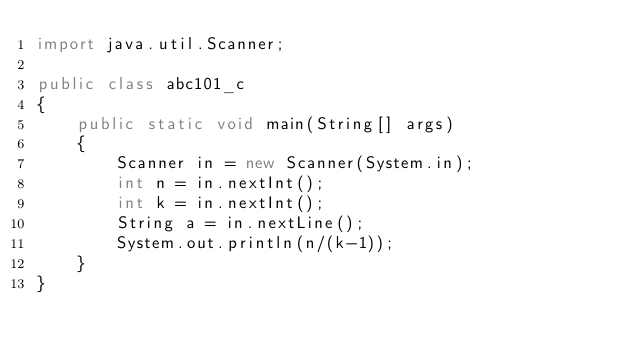<code> <loc_0><loc_0><loc_500><loc_500><_Java_>import java.util.Scanner;

public class abc101_c
{
    public static void main(String[] args)
    {
        Scanner in = new Scanner(System.in);
        int n = in.nextInt();
        int k = in.nextInt();
        String a = in.nextLine();
        System.out.println(n/(k-1));
    }
}
</code> 